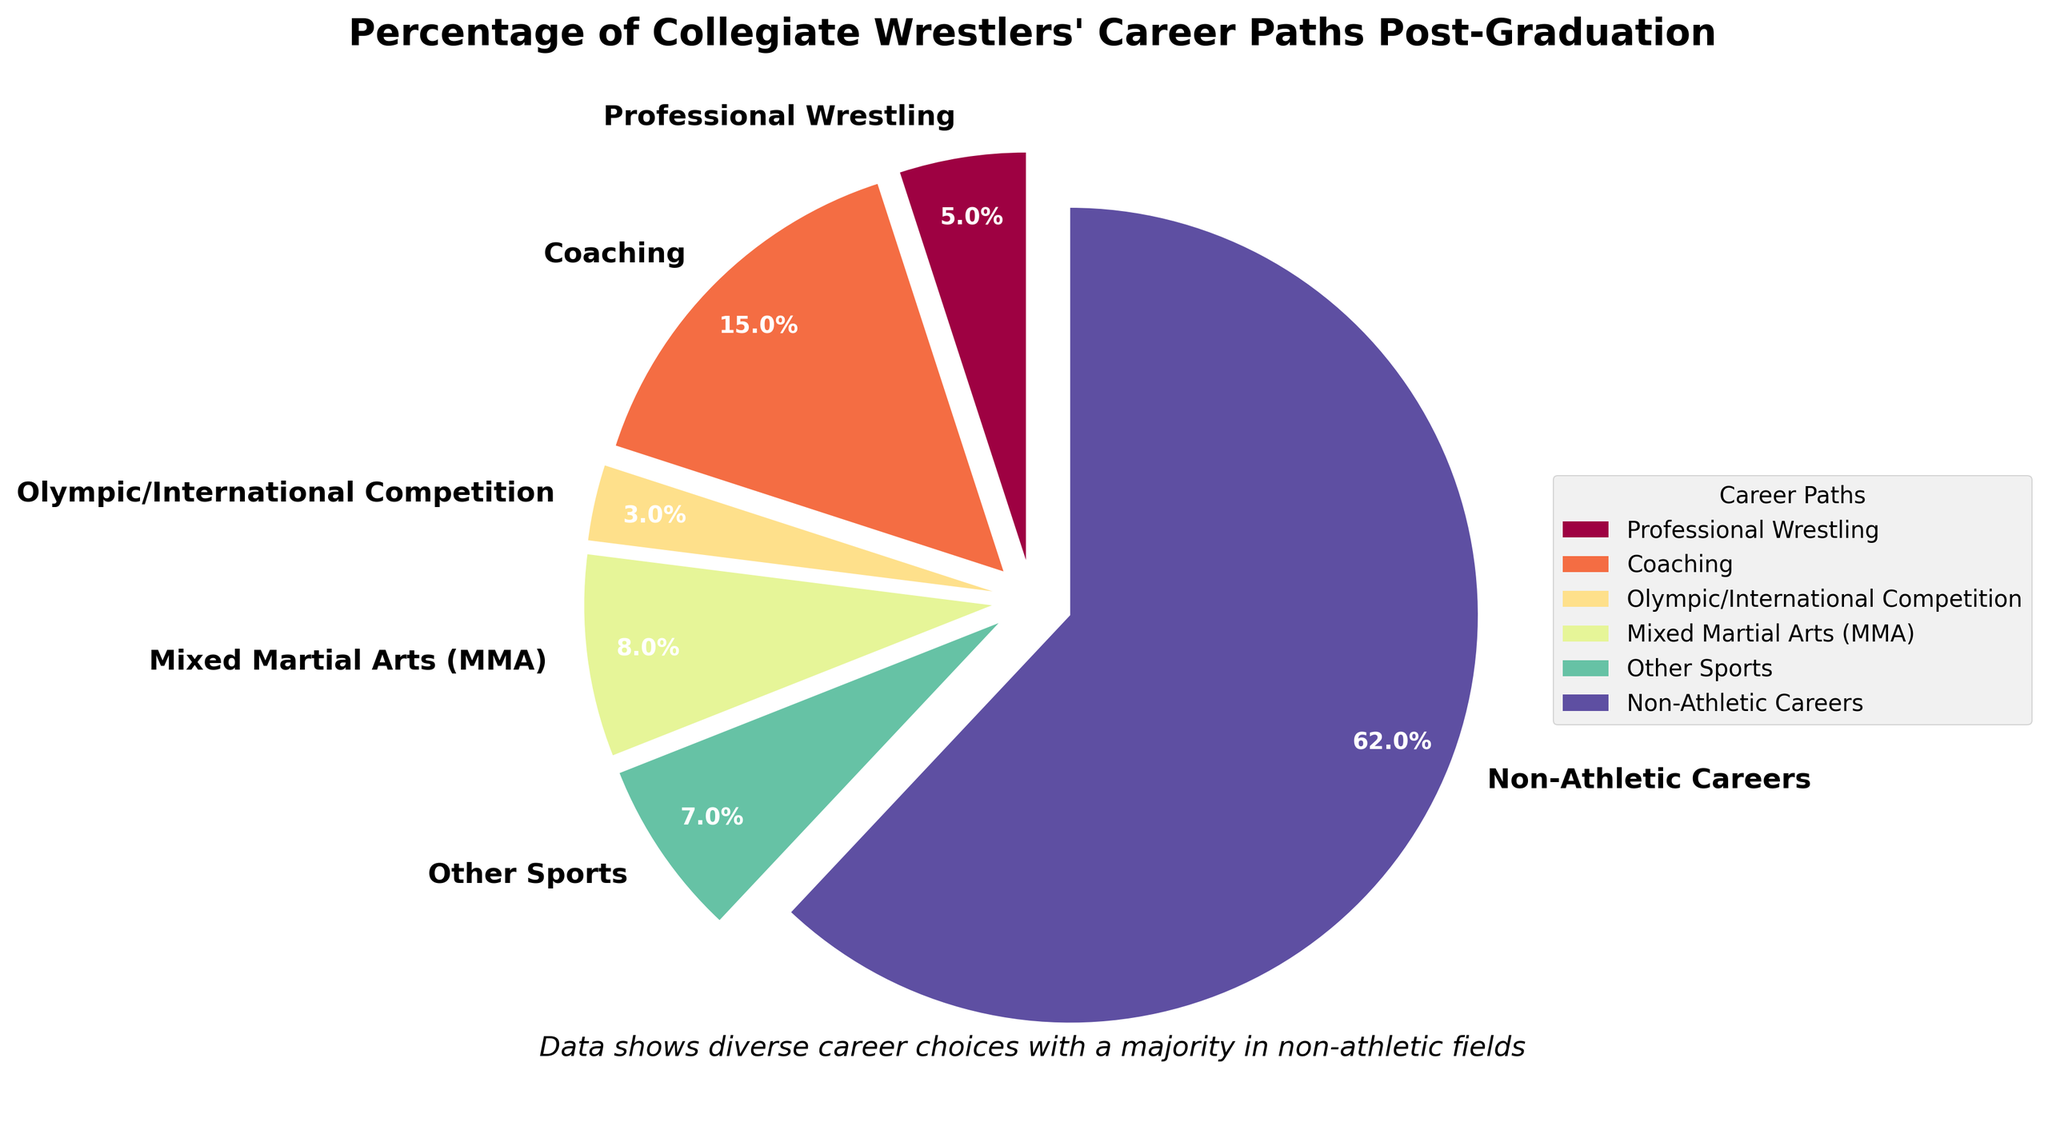Which career path has the highest percentage of collegiate wrestlers continuing post-graduation? By observing the pie chart, the largest wedge corresponds to "Non-Athletic Careers," indicating it has the highest percentage.
Answer: Non-Athletic Careers What is the combined percentage of collegiate wrestlers going into Coaching and MMA? The pie chart shows 15% for Coaching and 8% for MMA. Adding these together, 15% + 8% = 23%.
Answer: 23% Which career path has a smaller percentage, Professional Wrestling or Olympic/International Competition? By comparing the wedges, Professional Wrestling is 5%, and Olympic/International Competition is 3%. Therefore, Olympic/International Competition has a smaller percentage.
Answer: Olympic/International Competition How much more likely are collegiate wrestlers to pursue Coaching compared to Other Sports? The chart shows 15% for Coaching and 7% for Other Sports. Subtracting these values gives us 15% - 7% = 8%. Collegiate wrestlers are 8% more likely to pursue Coaching.
Answer: 8% Which career paths have a combined total percentage greater than 20% but less than 30%? Adding the percentages of different combinations and checking against the criterion, 15% (Coaching) + 8% (MMA) = 23%. This combination meets the criterion.
Answer: Coaching and MMA How do the percentages of collegiate wrestlers entering Non-Athletic Careers compare to those entering all athletic-related careers combined? Non-Athletic Careers stands at 62%. Summing the athletic-related careers (Professional Wrestling 5% + Coaching 15% + Olympic/International 3% + MMA 8% + Other Sports 7%), the total is 38%. Non-Athletic Careers (62%) > Athletic-related careers (38%).
Answer: Larger What is the average percentage of collegiate wrestlers in athletic-related careers (Professional Wrestling, Coaching, Olympic/International, MMA, Other Sports)? Adding the percentages of athletic-related careers 5% + 15% + 3% + 8% + 7% = 38%, then dividing by 5 (number of categories), the average is 38% / 5 = 7.6%.
Answer: 7.6% What is the ratio of collegiate wrestlers pursuing Coaching to those pursuing Professional Wrestling? The chart shows 15% for Coaching and 5% for Professional Wrestling. The ratio is 15% / 5% = 3.
Answer: 3 Which career path is represented by the lightest color in the chart? Observing the chart, the lightest color usually stands out as occupying the smallest section, which corresponds to Olympic/International Competition at 3%.
Answer: Olympic/International Competition 